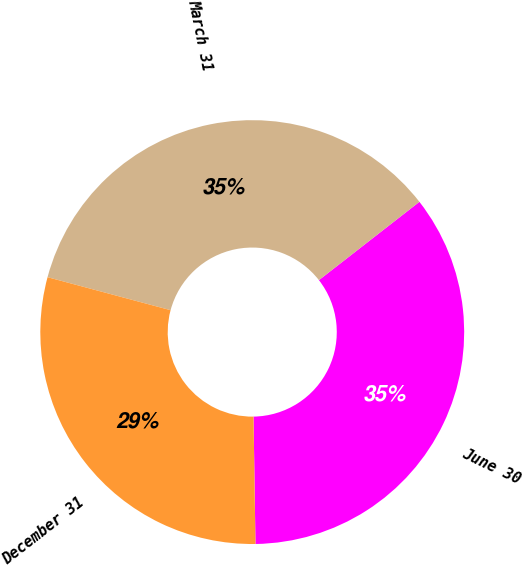Convert chart to OTSL. <chart><loc_0><loc_0><loc_500><loc_500><pie_chart><fcel>June 30<fcel>March 31<fcel>December 31<nl><fcel>35.29%<fcel>35.29%<fcel>29.41%<nl></chart> 